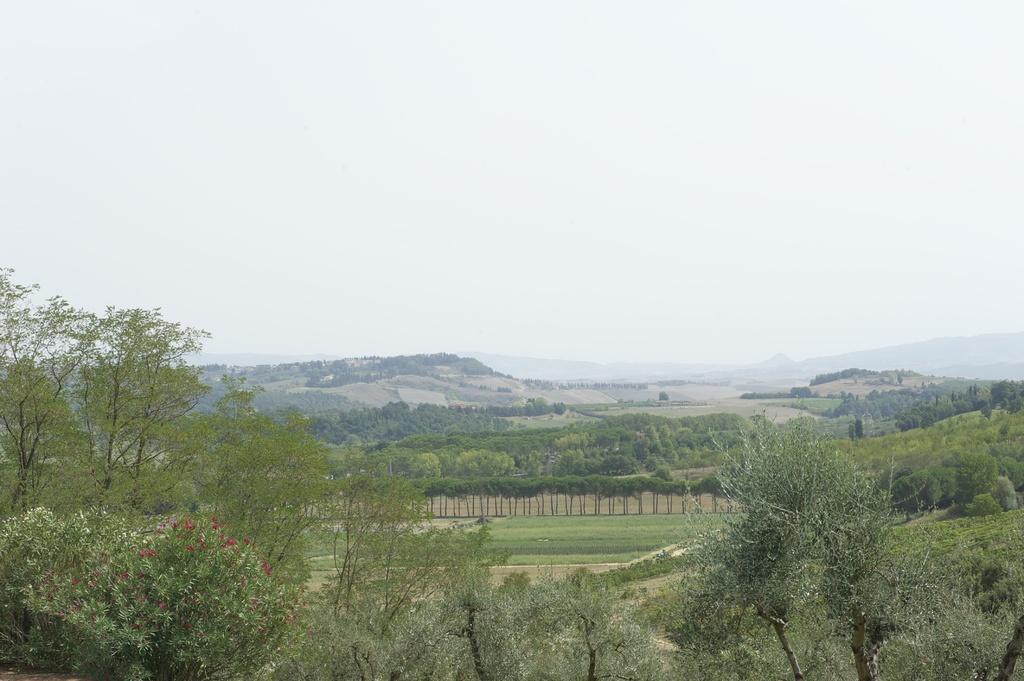Please provide a concise description of this image. In the picture we can see a part of the plant and behind it, we can see a grass surface and behind it also we can see some trees and in the background, we can see the hill covered with trees and behind it we can see the sky. 